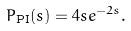<formula> <loc_0><loc_0><loc_500><loc_500>P _ { \text {PI} } ( s ) = 4 s e ^ { - 2 s } .</formula> 